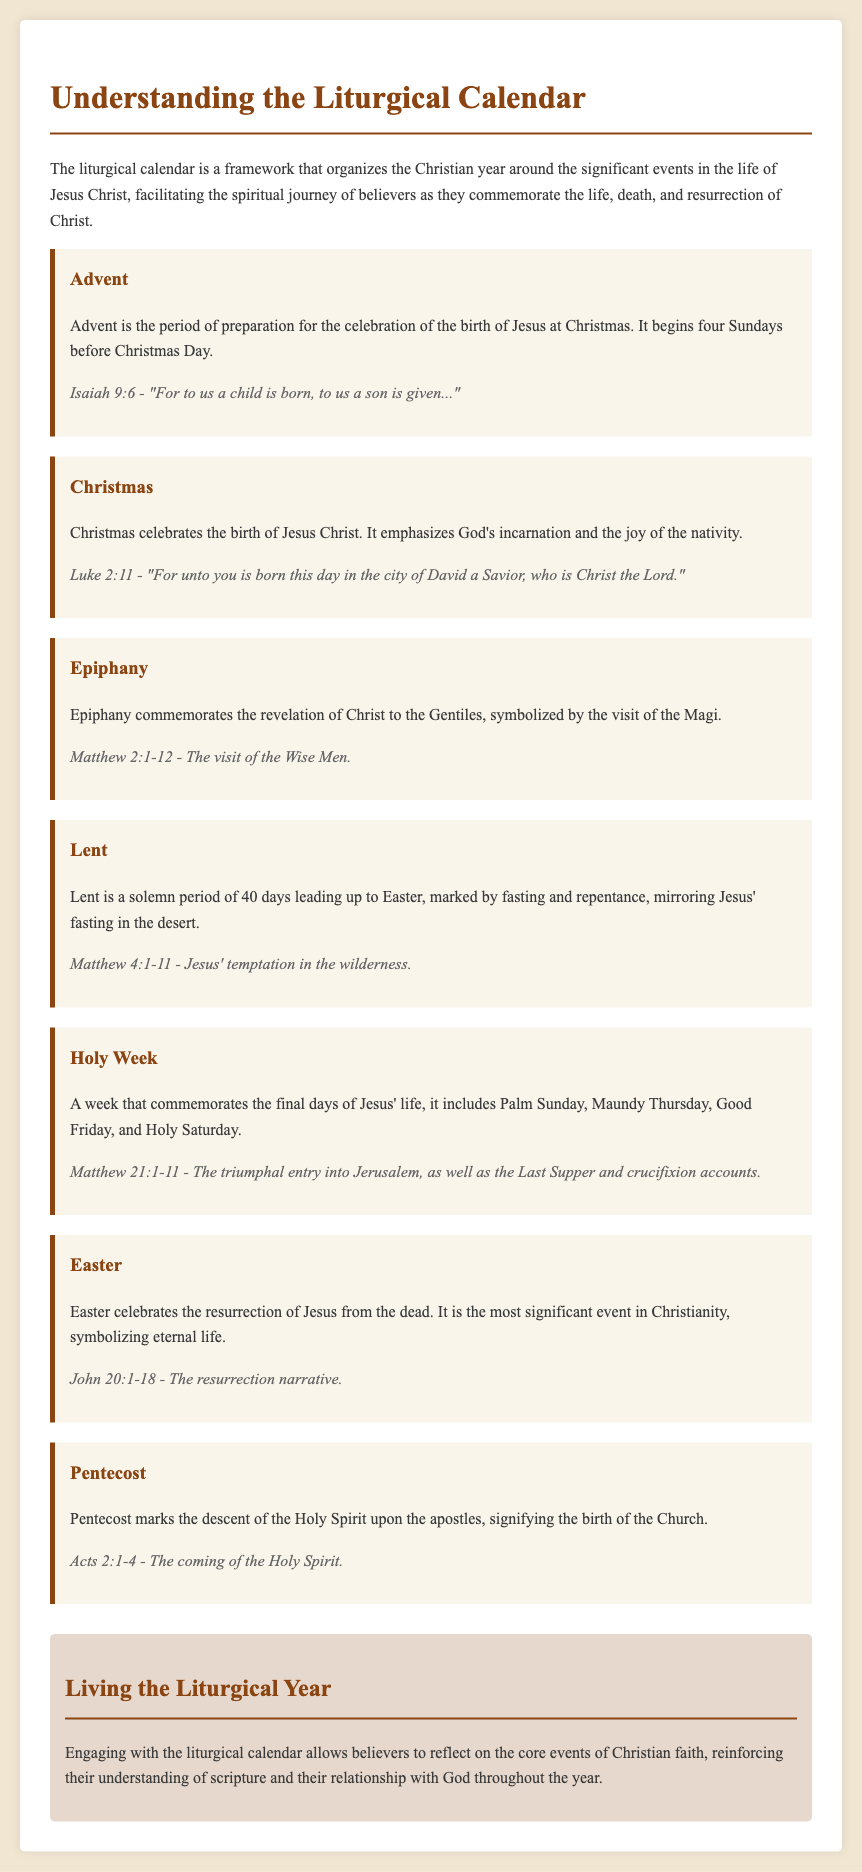what is the first season of the liturgical calendar? The document states that Advent is the first season of the liturgical calendar.
Answer: Advent what is the biblical reference for Christmas? The biblical reference for Christmas mentioned in the document is Luke 2:11.
Answer: Luke 2:11 how many days does Lent last? The document mentions that Lent lasts for 40 days.
Answer: 40 days what event does Epiphany commemorate? The document states that Epiphany commemorates the revelation of Christ to the Gentiles.
Answer: Revelation of Christ to the Gentiles which book contains the resurrection narrative? The resurrection narrative is found in the book of John according to the document.
Answer: John what significant event does Pentecost mark? The document specifies that Pentecost marks the descent of the Holy Spirit upon the apostles.
Answer: Descent of the Holy Spirit what is the last event mentioned in the liturgical calendar? The last event mentioned in the document is Pentecost.
Answer: Pentecost which day starts Holy Week? The document indicates that Palm Sunday starts Holy Week.
Answer: Palm Sunday how does the document describe the significance of Easter? The document describes Easter as the most significant event in Christianity, symbolizing eternal life.
Answer: Most significant event in Christianity, symbolizing eternal life 